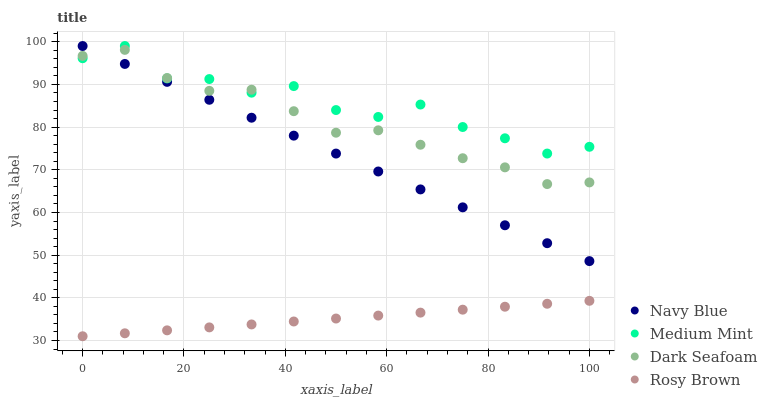Does Rosy Brown have the minimum area under the curve?
Answer yes or no. Yes. Does Medium Mint have the maximum area under the curve?
Answer yes or no. Yes. Does Navy Blue have the minimum area under the curve?
Answer yes or no. No. Does Navy Blue have the maximum area under the curve?
Answer yes or no. No. Is Rosy Brown the smoothest?
Answer yes or no. Yes. Is Medium Mint the roughest?
Answer yes or no. Yes. Is Navy Blue the smoothest?
Answer yes or no. No. Is Navy Blue the roughest?
Answer yes or no. No. Does Rosy Brown have the lowest value?
Answer yes or no. Yes. Does Navy Blue have the lowest value?
Answer yes or no. No. Does Navy Blue have the highest value?
Answer yes or no. Yes. Does Dark Seafoam have the highest value?
Answer yes or no. No. Is Rosy Brown less than Navy Blue?
Answer yes or no. Yes. Is Medium Mint greater than Rosy Brown?
Answer yes or no. Yes. Does Dark Seafoam intersect Navy Blue?
Answer yes or no. Yes. Is Dark Seafoam less than Navy Blue?
Answer yes or no. No. Is Dark Seafoam greater than Navy Blue?
Answer yes or no. No. Does Rosy Brown intersect Navy Blue?
Answer yes or no. No. 